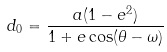Convert formula to latex. <formula><loc_0><loc_0><loc_500><loc_500>d _ { 0 } = \frac { a ( 1 - e ^ { 2 } ) } { 1 + e \cos ( \theta - \omega ) }</formula> 